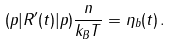<formula> <loc_0><loc_0><loc_500><loc_500>( p | R ^ { \prime } ( t ) | p ) \frac { n } { k _ { B } T } = \eta _ { b } ( t ) \, .</formula> 